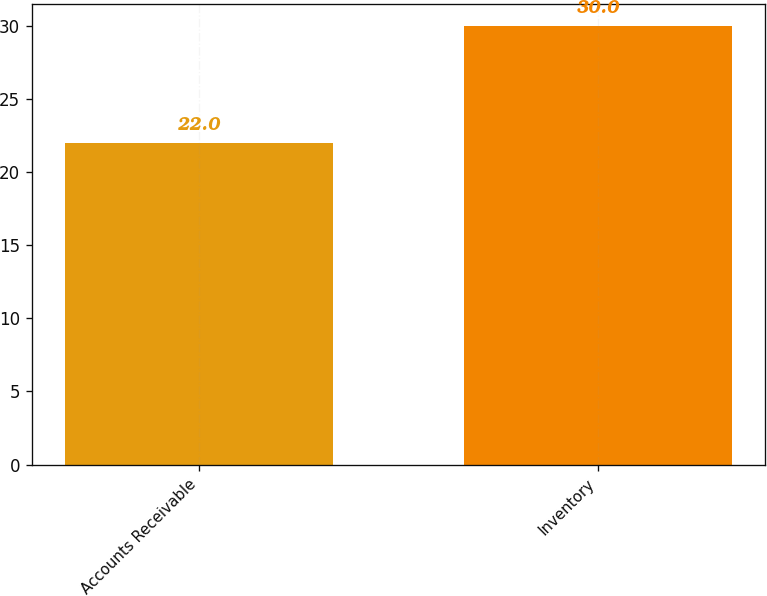Convert chart. <chart><loc_0><loc_0><loc_500><loc_500><bar_chart><fcel>Accounts Receivable<fcel>Inventory<nl><fcel>22<fcel>30<nl></chart> 